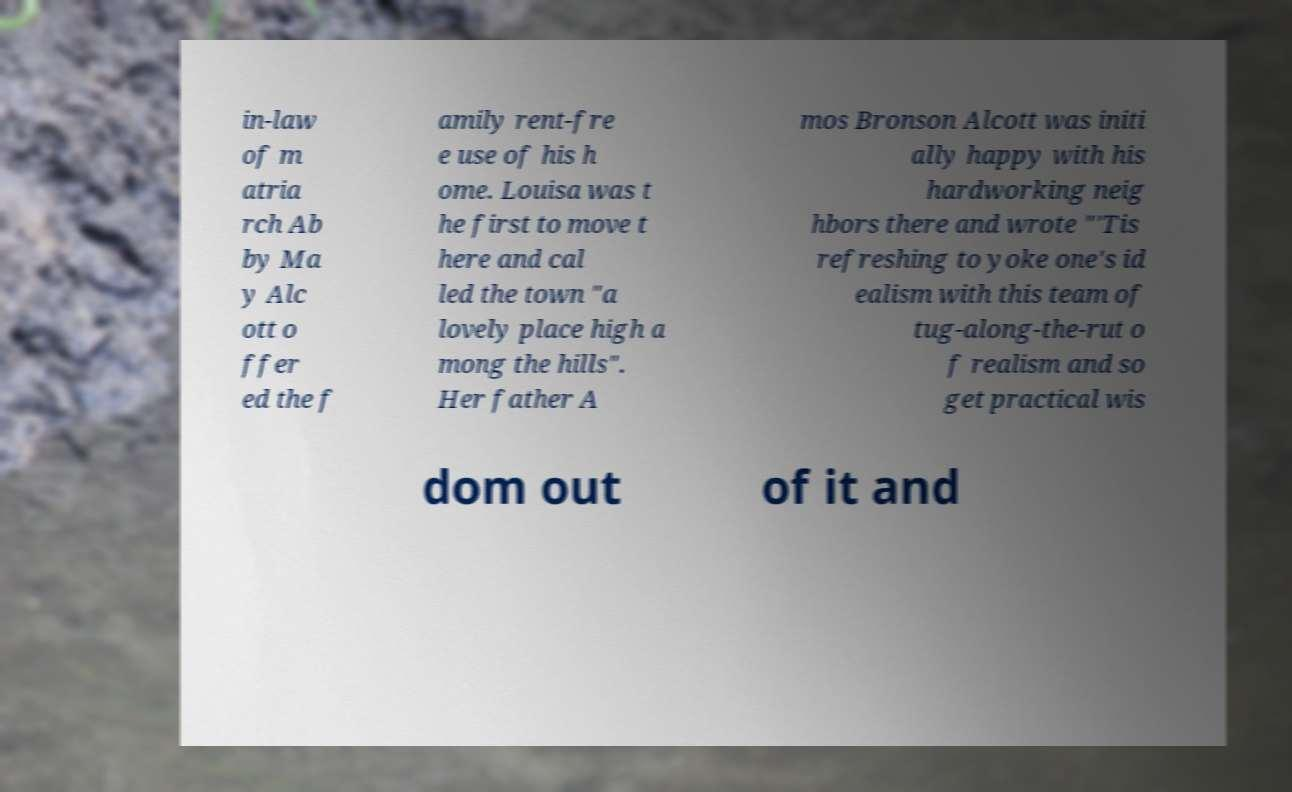For documentation purposes, I need the text within this image transcribed. Could you provide that? in-law of m atria rch Ab by Ma y Alc ott o ffer ed the f amily rent-fre e use of his h ome. Louisa was t he first to move t here and cal led the town "a lovely place high a mong the hills". Her father A mos Bronson Alcott was initi ally happy with his hardworking neig hbors there and wrote "'Tis refreshing to yoke one's id ealism with this team of tug-along-the-rut o f realism and so get practical wis dom out of it and 